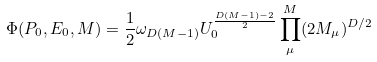Convert formula to latex. <formula><loc_0><loc_0><loc_500><loc_500>\Phi ( { P } _ { 0 } , E _ { 0 } , M ) = \frac { 1 } { 2 } \omega _ { D ( M - 1 ) } U _ { 0 } ^ { \frac { D ( M - 1 ) - 2 } { 2 } } \prod _ { \mu } ^ { M } ( 2 M _ { \mu } ) ^ { D / 2 }</formula> 